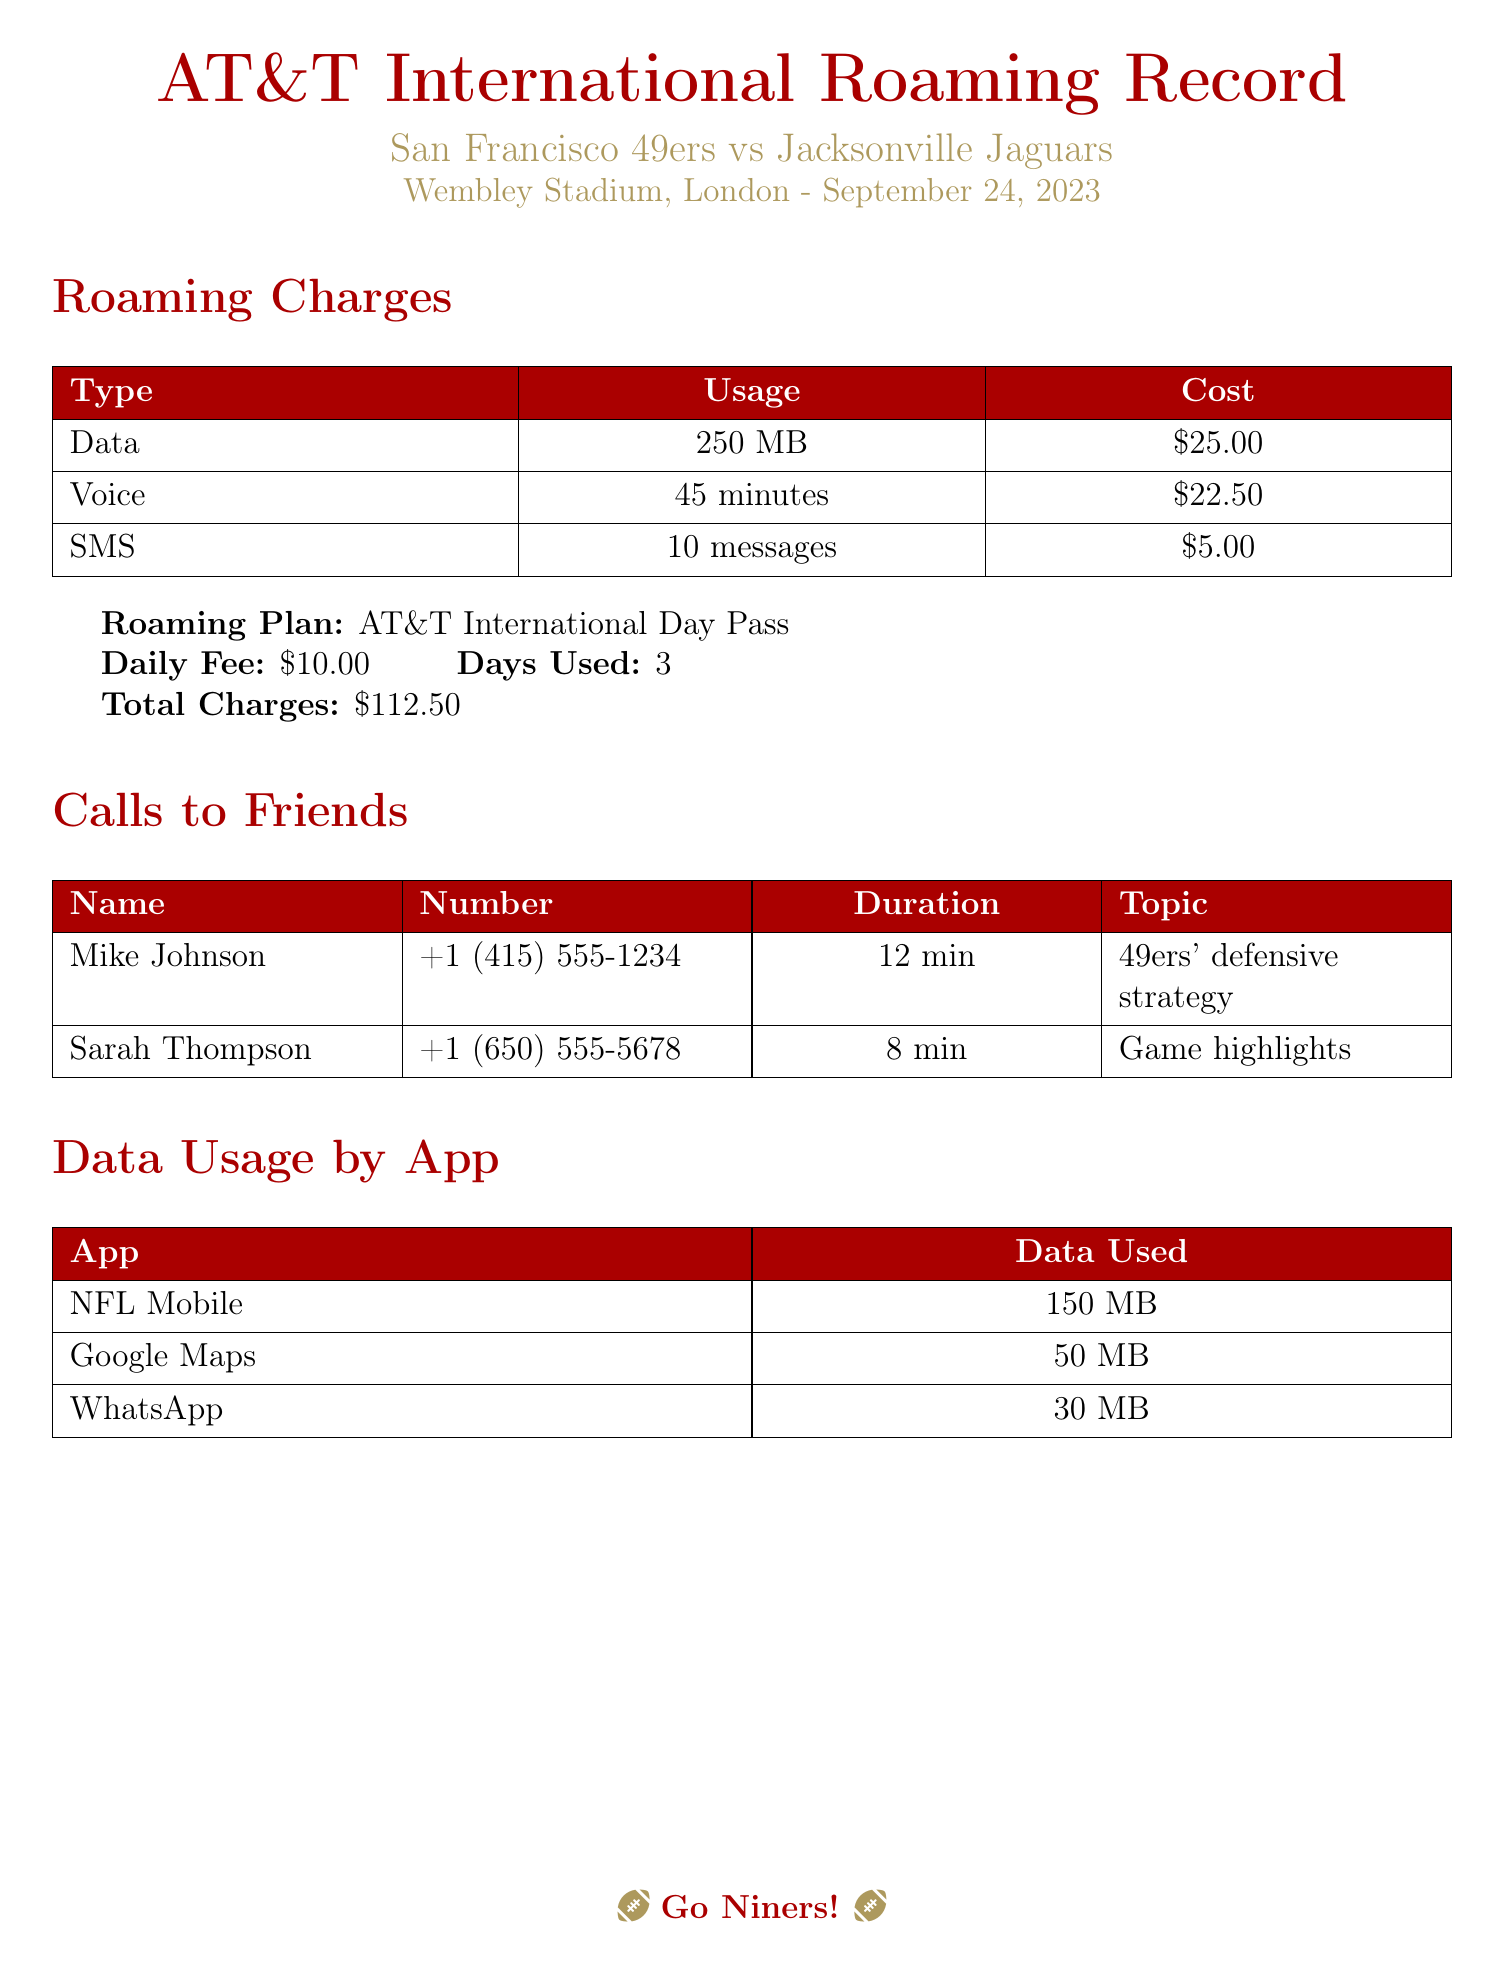what is the total cost of the roaming charges? The total cost of the roaming charges is explicitly stated as $112.50 in the document.
Answer: $112.50 how many minutes of voice were used? The document lists a total of 45 minutes of voice usage for calls made while roaming.
Answer: 45 minutes what is the daily fee for the roaming plan? The daily fee for the roaming plan is noted in the document as $10.00.
Answer: $10.00 which app used the most data? The document indicates that the NFL Mobile app used the most data at 150 MB.
Answer: NFL Mobile how many days was the roaming plan used? The document specifies that the roaming plan was used for 3 days during the trip.
Answer: 3 days who was called for discussing game highlights? The document mentions that Sarah Thompson was called to discuss game highlights.
Answer: Sarah Thompson what was the cost of sending SMS messages? The document states that sending 10 SMS messages incurred a cost of $5.00.
Answer: $5.00 how much data was used on Google Maps? According to the document, Google Maps used 50 MB of data during the roaming period.
Answer: 50 MB what is the total duration of calls made to friends? The durations of the two calls made are 12 minutes and 8 minutes, totaling 20 minutes of calls.
Answer: 20 minutes 